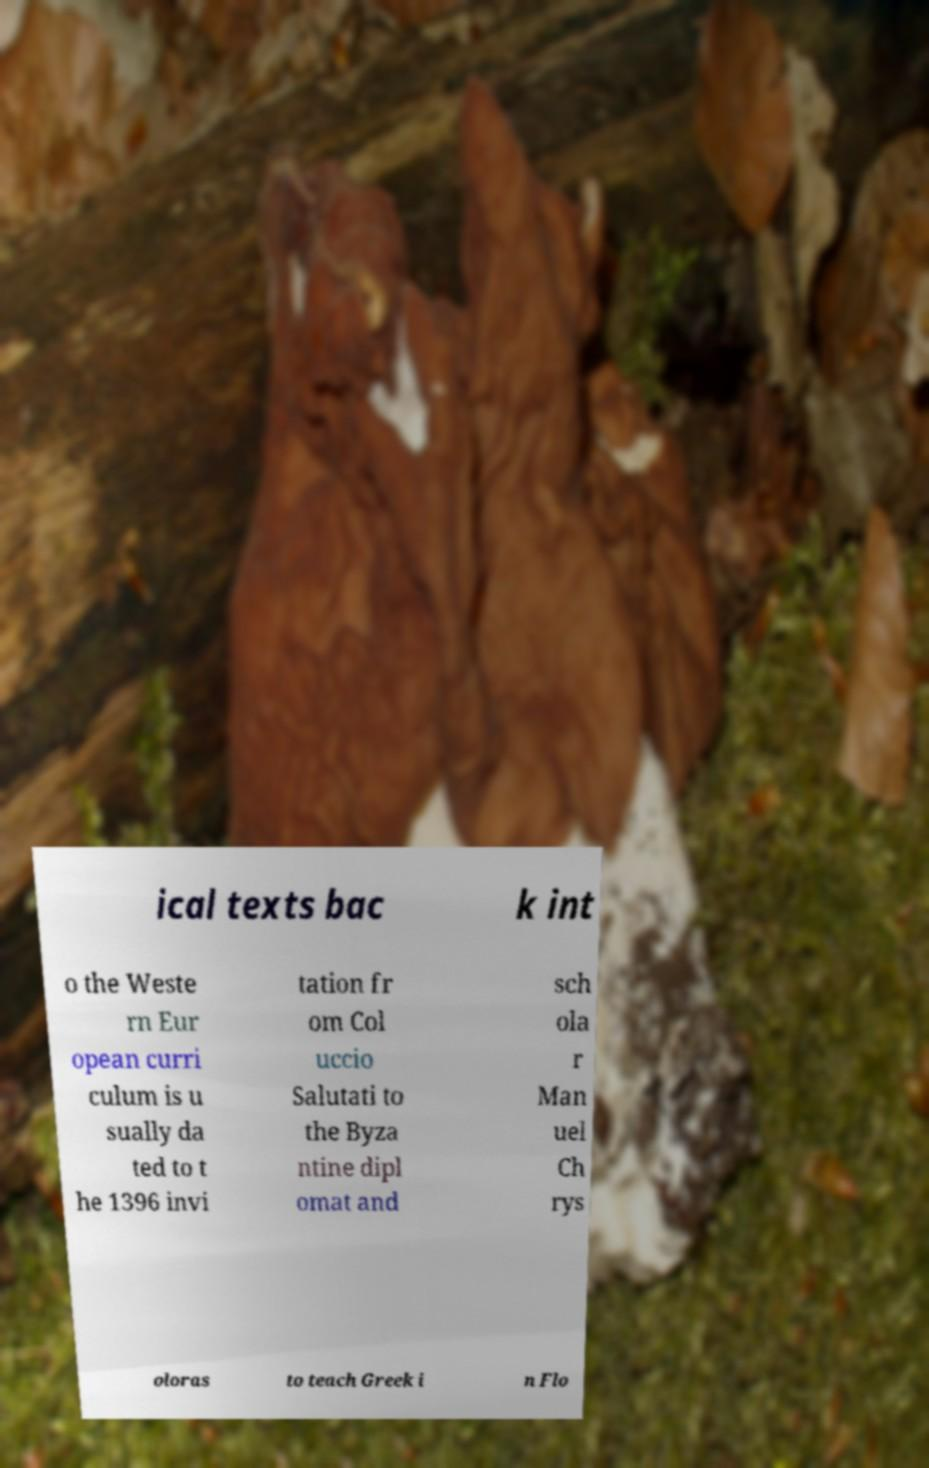What messages or text are displayed in this image? I need them in a readable, typed format. ical texts bac k int o the Weste rn Eur opean curri culum is u sually da ted to t he 1396 invi tation fr om Col uccio Salutati to the Byza ntine dipl omat and sch ola r Man uel Ch rys oloras to teach Greek i n Flo 